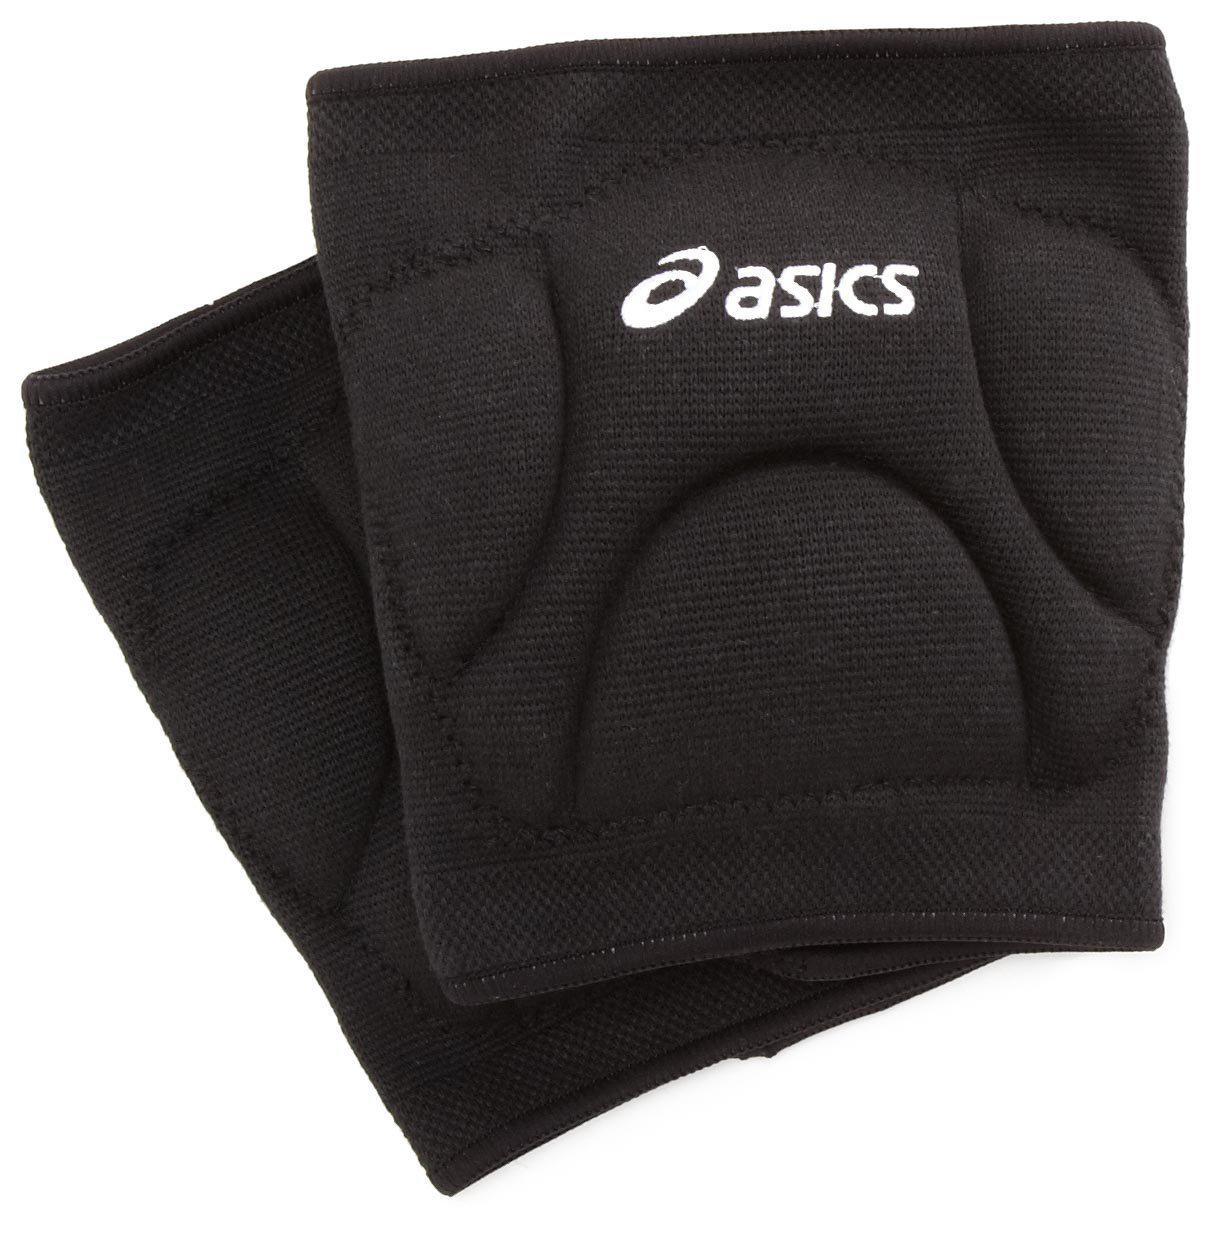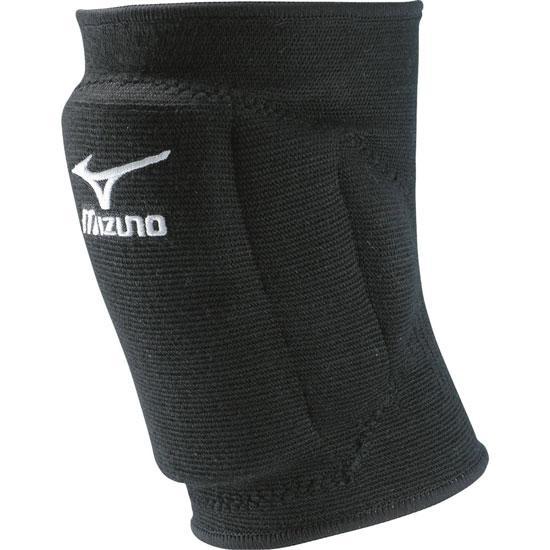The first image is the image on the left, the second image is the image on the right. Examine the images to the left and right. Is the description "One of the paired images contains one black brace and one white brace." accurate? Answer yes or no. No. 